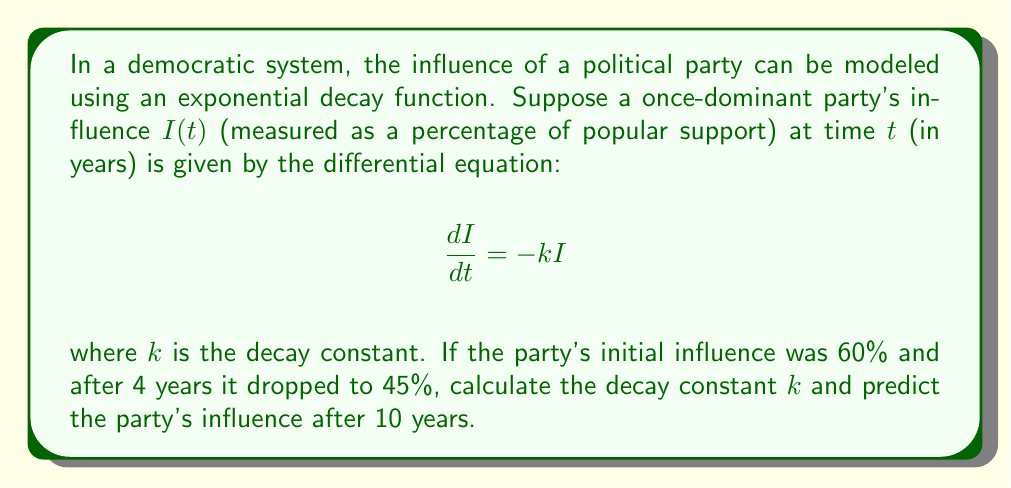Help me with this question. To solve this problem, we'll follow these steps:

1) The general solution to the differential equation $\frac{dI}{dt} = -kI$ is:

   $$I(t) = I_0e^{-kt}$$

   where $I_0$ is the initial influence.

2) We're given that $I_0 = 60\%$ and $I(4) = 45\%$. Let's substitute these into our equation:

   $$45 = 60e^{-4k}$$

3) Divide both sides by 60:

   $$\frac{45}{60} = e^{-4k}$$

4) Take the natural logarithm of both sides:

   $$\ln(\frac{45}{60}) = -4k$$

5) Solve for $k$:

   $$k = -\frac{1}{4}\ln(\frac{45}{60}) \approx 0.0722$$

6) Now that we have $k$, we can predict the influence after 10 years by using our original equation:

   $$I(10) = 60e^{-0.0722 * 10}$$

7) Calculate this value:

   $$I(10) = 60e^{-0.722} \approx 29.14\%$$
Answer: The decay constant $k$ is approximately 0.0722 per year, and the party's predicted influence after 10 years is approximately 29.14%. 